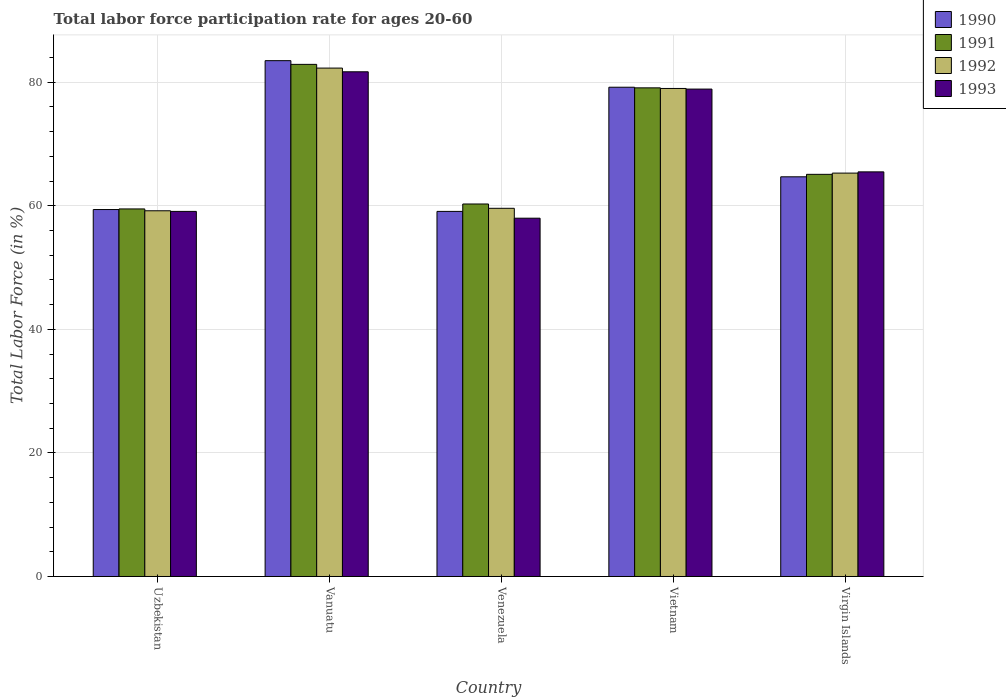Are the number of bars on each tick of the X-axis equal?
Make the answer very short. Yes. How many bars are there on the 1st tick from the left?
Ensure brevity in your answer.  4. What is the label of the 5th group of bars from the left?
Your answer should be compact. Virgin Islands. What is the labor force participation rate in 1990 in Virgin Islands?
Give a very brief answer. 64.7. Across all countries, what is the maximum labor force participation rate in 1993?
Your answer should be compact. 81.7. Across all countries, what is the minimum labor force participation rate in 1990?
Make the answer very short. 59.1. In which country was the labor force participation rate in 1991 maximum?
Offer a terse response. Vanuatu. In which country was the labor force participation rate in 1993 minimum?
Offer a very short reply. Venezuela. What is the total labor force participation rate in 1990 in the graph?
Keep it short and to the point. 345.9. What is the difference between the labor force participation rate in 1990 in Venezuela and that in Virgin Islands?
Your answer should be compact. -5.6. What is the difference between the labor force participation rate in 1992 in Vanuatu and the labor force participation rate in 1993 in Virgin Islands?
Ensure brevity in your answer.  16.8. What is the average labor force participation rate in 1993 per country?
Offer a terse response. 68.64. What is the difference between the labor force participation rate of/in 1990 and labor force participation rate of/in 1991 in Virgin Islands?
Your response must be concise. -0.4. What is the ratio of the labor force participation rate in 1991 in Venezuela to that in Vietnam?
Ensure brevity in your answer.  0.76. Is the difference between the labor force participation rate in 1990 in Vanuatu and Virgin Islands greater than the difference between the labor force participation rate in 1991 in Vanuatu and Virgin Islands?
Offer a terse response. Yes. What is the difference between the highest and the lowest labor force participation rate in 1992?
Give a very brief answer. 23.1. Is the sum of the labor force participation rate in 1992 in Venezuela and Vietnam greater than the maximum labor force participation rate in 1993 across all countries?
Offer a terse response. Yes. What does the 4th bar from the left in Virgin Islands represents?
Provide a short and direct response. 1993. Is it the case that in every country, the sum of the labor force participation rate in 1991 and labor force participation rate in 1993 is greater than the labor force participation rate in 1992?
Your answer should be compact. Yes. How many bars are there?
Your answer should be very brief. 20. Are all the bars in the graph horizontal?
Offer a terse response. No. How many countries are there in the graph?
Keep it short and to the point. 5. Does the graph contain grids?
Keep it short and to the point. Yes. Where does the legend appear in the graph?
Offer a very short reply. Top right. What is the title of the graph?
Your answer should be compact. Total labor force participation rate for ages 20-60. Does "1989" appear as one of the legend labels in the graph?
Provide a succinct answer. No. What is the Total Labor Force (in %) of 1990 in Uzbekistan?
Offer a terse response. 59.4. What is the Total Labor Force (in %) in 1991 in Uzbekistan?
Your response must be concise. 59.5. What is the Total Labor Force (in %) of 1992 in Uzbekistan?
Offer a terse response. 59.2. What is the Total Labor Force (in %) of 1993 in Uzbekistan?
Provide a succinct answer. 59.1. What is the Total Labor Force (in %) in 1990 in Vanuatu?
Your response must be concise. 83.5. What is the Total Labor Force (in %) of 1991 in Vanuatu?
Your response must be concise. 82.9. What is the Total Labor Force (in %) in 1992 in Vanuatu?
Give a very brief answer. 82.3. What is the Total Labor Force (in %) of 1993 in Vanuatu?
Keep it short and to the point. 81.7. What is the Total Labor Force (in %) of 1990 in Venezuela?
Your answer should be compact. 59.1. What is the Total Labor Force (in %) of 1991 in Venezuela?
Provide a short and direct response. 60.3. What is the Total Labor Force (in %) in 1992 in Venezuela?
Offer a terse response. 59.6. What is the Total Labor Force (in %) in 1993 in Venezuela?
Make the answer very short. 58. What is the Total Labor Force (in %) in 1990 in Vietnam?
Offer a very short reply. 79.2. What is the Total Labor Force (in %) in 1991 in Vietnam?
Give a very brief answer. 79.1. What is the Total Labor Force (in %) of 1992 in Vietnam?
Ensure brevity in your answer.  79. What is the Total Labor Force (in %) in 1993 in Vietnam?
Your answer should be compact. 78.9. What is the Total Labor Force (in %) of 1990 in Virgin Islands?
Offer a terse response. 64.7. What is the Total Labor Force (in %) of 1991 in Virgin Islands?
Your response must be concise. 65.1. What is the Total Labor Force (in %) in 1992 in Virgin Islands?
Offer a very short reply. 65.3. What is the Total Labor Force (in %) of 1993 in Virgin Islands?
Provide a succinct answer. 65.5. Across all countries, what is the maximum Total Labor Force (in %) in 1990?
Make the answer very short. 83.5. Across all countries, what is the maximum Total Labor Force (in %) of 1991?
Your answer should be very brief. 82.9. Across all countries, what is the maximum Total Labor Force (in %) of 1992?
Ensure brevity in your answer.  82.3. Across all countries, what is the maximum Total Labor Force (in %) in 1993?
Offer a terse response. 81.7. Across all countries, what is the minimum Total Labor Force (in %) in 1990?
Provide a succinct answer. 59.1. Across all countries, what is the minimum Total Labor Force (in %) of 1991?
Ensure brevity in your answer.  59.5. Across all countries, what is the minimum Total Labor Force (in %) of 1992?
Keep it short and to the point. 59.2. What is the total Total Labor Force (in %) in 1990 in the graph?
Offer a terse response. 345.9. What is the total Total Labor Force (in %) in 1991 in the graph?
Keep it short and to the point. 346.9. What is the total Total Labor Force (in %) of 1992 in the graph?
Give a very brief answer. 345.4. What is the total Total Labor Force (in %) in 1993 in the graph?
Your answer should be compact. 343.2. What is the difference between the Total Labor Force (in %) in 1990 in Uzbekistan and that in Vanuatu?
Offer a very short reply. -24.1. What is the difference between the Total Labor Force (in %) of 1991 in Uzbekistan and that in Vanuatu?
Provide a succinct answer. -23.4. What is the difference between the Total Labor Force (in %) of 1992 in Uzbekistan and that in Vanuatu?
Offer a terse response. -23.1. What is the difference between the Total Labor Force (in %) in 1993 in Uzbekistan and that in Vanuatu?
Give a very brief answer. -22.6. What is the difference between the Total Labor Force (in %) in 1990 in Uzbekistan and that in Venezuela?
Keep it short and to the point. 0.3. What is the difference between the Total Labor Force (in %) of 1991 in Uzbekistan and that in Venezuela?
Make the answer very short. -0.8. What is the difference between the Total Labor Force (in %) in 1992 in Uzbekistan and that in Venezuela?
Your answer should be compact. -0.4. What is the difference between the Total Labor Force (in %) of 1993 in Uzbekistan and that in Venezuela?
Provide a short and direct response. 1.1. What is the difference between the Total Labor Force (in %) in 1990 in Uzbekistan and that in Vietnam?
Provide a succinct answer. -19.8. What is the difference between the Total Labor Force (in %) in 1991 in Uzbekistan and that in Vietnam?
Give a very brief answer. -19.6. What is the difference between the Total Labor Force (in %) in 1992 in Uzbekistan and that in Vietnam?
Ensure brevity in your answer.  -19.8. What is the difference between the Total Labor Force (in %) of 1993 in Uzbekistan and that in Vietnam?
Your answer should be compact. -19.8. What is the difference between the Total Labor Force (in %) of 1992 in Uzbekistan and that in Virgin Islands?
Your response must be concise. -6.1. What is the difference between the Total Labor Force (in %) in 1990 in Vanuatu and that in Venezuela?
Ensure brevity in your answer.  24.4. What is the difference between the Total Labor Force (in %) of 1991 in Vanuatu and that in Venezuela?
Give a very brief answer. 22.6. What is the difference between the Total Labor Force (in %) of 1992 in Vanuatu and that in Venezuela?
Offer a terse response. 22.7. What is the difference between the Total Labor Force (in %) of 1993 in Vanuatu and that in Venezuela?
Your response must be concise. 23.7. What is the difference between the Total Labor Force (in %) of 1990 in Vanuatu and that in Vietnam?
Keep it short and to the point. 4.3. What is the difference between the Total Labor Force (in %) of 1991 in Vanuatu and that in Vietnam?
Ensure brevity in your answer.  3.8. What is the difference between the Total Labor Force (in %) of 1993 in Vanuatu and that in Vietnam?
Offer a very short reply. 2.8. What is the difference between the Total Labor Force (in %) in 1990 in Venezuela and that in Vietnam?
Offer a very short reply. -20.1. What is the difference between the Total Labor Force (in %) of 1991 in Venezuela and that in Vietnam?
Your response must be concise. -18.8. What is the difference between the Total Labor Force (in %) of 1992 in Venezuela and that in Vietnam?
Your response must be concise. -19.4. What is the difference between the Total Labor Force (in %) in 1993 in Venezuela and that in Vietnam?
Your answer should be compact. -20.9. What is the difference between the Total Labor Force (in %) of 1992 in Venezuela and that in Virgin Islands?
Your answer should be very brief. -5.7. What is the difference between the Total Labor Force (in %) in 1990 in Vietnam and that in Virgin Islands?
Offer a very short reply. 14.5. What is the difference between the Total Labor Force (in %) of 1990 in Uzbekistan and the Total Labor Force (in %) of 1991 in Vanuatu?
Ensure brevity in your answer.  -23.5. What is the difference between the Total Labor Force (in %) of 1990 in Uzbekistan and the Total Labor Force (in %) of 1992 in Vanuatu?
Give a very brief answer. -22.9. What is the difference between the Total Labor Force (in %) in 1990 in Uzbekistan and the Total Labor Force (in %) in 1993 in Vanuatu?
Give a very brief answer. -22.3. What is the difference between the Total Labor Force (in %) in 1991 in Uzbekistan and the Total Labor Force (in %) in 1992 in Vanuatu?
Offer a terse response. -22.8. What is the difference between the Total Labor Force (in %) in 1991 in Uzbekistan and the Total Labor Force (in %) in 1993 in Vanuatu?
Offer a very short reply. -22.2. What is the difference between the Total Labor Force (in %) in 1992 in Uzbekistan and the Total Labor Force (in %) in 1993 in Vanuatu?
Offer a terse response. -22.5. What is the difference between the Total Labor Force (in %) of 1990 in Uzbekistan and the Total Labor Force (in %) of 1992 in Venezuela?
Give a very brief answer. -0.2. What is the difference between the Total Labor Force (in %) in 1990 in Uzbekistan and the Total Labor Force (in %) in 1993 in Venezuela?
Your answer should be very brief. 1.4. What is the difference between the Total Labor Force (in %) of 1991 in Uzbekistan and the Total Labor Force (in %) of 1993 in Venezuela?
Offer a very short reply. 1.5. What is the difference between the Total Labor Force (in %) of 1992 in Uzbekistan and the Total Labor Force (in %) of 1993 in Venezuela?
Offer a very short reply. 1.2. What is the difference between the Total Labor Force (in %) of 1990 in Uzbekistan and the Total Labor Force (in %) of 1991 in Vietnam?
Offer a very short reply. -19.7. What is the difference between the Total Labor Force (in %) of 1990 in Uzbekistan and the Total Labor Force (in %) of 1992 in Vietnam?
Ensure brevity in your answer.  -19.6. What is the difference between the Total Labor Force (in %) of 1990 in Uzbekistan and the Total Labor Force (in %) of 1993 in Vietnam?
Your response must be concise. -19.5. What is the difference between the Total Labor Force (in %) of 1991 in Uzbekistan and the Total Labor Force (in %) of 1992 in Vietnam?
Offer a very short reply. -19.5. What is the difference between the Total Labor Force (in %) of 1991 in Uzbekistan and the Total Labor Force (in %) of 1993 in Vietnam?
Your answer should be very brief. -19.4. What is the difference between the Total Labor Force (in %) in 1992 in Uzbekistan and the Total Labor Force (in %) in 1993 in Vietnam?
Ensure brevity in your answer.  -19.7. What is the difference between the Total Labor Force (in %) of 1990 in Uzbekistan and the Total Labor Force (in %) of 1993 in Virgin Islands?
Your answer should be very brief. -6.1. What is the difference between the Total Labor Force (in %) of 1991 in Uzbekistan and the Total Labor Force (in %) of 1992 in Virgin Islands?
Offer a very short reply. -5.8. What is the difference between the Total Labor Force (in %) in 1992 in Uzbekistan and the Total Labor Force (in %) in 1993 in Virgin Islands?
Provide a short and direct response. -6.3. What is the difference between the Total Labor Force (in %) of 1990 in Vanuatu and the Total Labor Force (in %) of 1991 in Venezuela?
Ensure brevity in your answer.  23.2. What is the difference between the Total Labor Force (in %) in 1990 in Vanuatu and the Total Labor Force (in %) in 1992 in Venezuela?
Make the answer very short. 23.9. What is the difference between the Total Labor Force (in %) in 1990 in Vanuatu and the Total Labor Force (in %) in 1993 in Venezuela?
Offer a terse response. 25.5. What is the difference between the Total Labor Force (in %) in 1991 in Vanuatu and the Total Labor Force (in %) in 1992 in Venezuela?
Your response must be concise. 23.3. What is the difference between the Total Labor Force (in %) in 1991 in Vanuatu and the Total Labor Force (in %) in 1993 in Venezuela?
Offer a terse response. 24.9. What is the difference between the Total Labor Force (in %) in 1992 in Vanuatu and the Total Labor Force (in %) in 1993 in Venezuela?
Offer a very short reply. 24.3. What is the difference between the Total Labor Force (in %) of 1990 in Vanuatu and the Total Labor Force (in %) of 1991 in Vietnam?
Your response must be concise. 4.4. What is the difference between the Total Labor Force (in %) in 1990 in Vanuatu and the Total Labor Force (in %) in 1992 in Vietnam?
Keep it short and to the point. 4.5. What is the difference between the Total Labor Force (in %) in 1992 in Vanuatu and the Total Labor Force (in %) in 1993 in Vietnam?
Give a very brief answer. 3.4. What is the difference between the Total Labor Force (in %) of 1991 in Vanuatu and the Total Labor Force (in %) of 1993 in Virgin Islands?
Offer a terse response. 17.4. What is the difference between the Total Labor Force (in %) of 1990 in Venezuela and the Total Labor Force (in %) of 1992 in Vietnam?
Ensure brevity in your answer.  -19.9. What is the difference between the Total Labor Force (in %) of 1990 in Venezuela and the Total Labor Force (in %) of 1993 in Vietnam?
Your response must be concise. -19.8. What is the difference between the Total Labor Force (in %) in 1991 in Venezuela and the Total Labor Force (in %) in 1992 in Vietnam?
Make the answer very short. -18.7. What is the difference between the Total Labor Force (in %) of 1991 in Venezuela and the Total Labor Force (in %) of 1993 in Vietnam?
Give a very brief answer. -18.6. What is the difference between the Total Labor Force (in %) in 1992 in Venezuela and the Total Labor Force (in %) in 1993 in Vietnam?
Give a very brief answer. -19.3. What is the difference between the Total Labor Force (in %) of 1990 in Venezuela and the Total Labor Force (in %) of 1991 in Virgin Islands?
Offer a very short reply. -6. What is the difference between the Total Labor Force (in %) of 1990 in Venezuela and the Total Labor Force (in %) of 1993 in Virgin Islands?
Your answer should be compact. -6.4. What is the difference between the Total Labor Force (in %) in 1992 in Venezuela and the Total Labor Force (in %) in 1993 in Virgin Islands?
Ensure brevity in your answer.  -5.9. What is the difference between the Total Labor Force (in %) in 1990 in Vietnam and the Total Labor Force (in %) in 1991 in Virgin Islands?
Give a very brief answer. 14.1. What is the difference between the Total Labor Force (in %) in 1990 in Vietnam and the Total Labor Force (in %) in 1992 in Virgin Islands?
Provide a succinct answer. 13.9. What is the difference between the Total Labor Force (in %) in 1991 in Vietnam and the Total Labor Force (in %) in 1992 in Virgin Islands?
Offer a very short reply. 13.8. What is the difference between the Total Labor Force (in %) in 1991 in Vietnam and the Total Labor Force (in %) in 1993 in Virgin Islands?
Offer a terse response. 13.6. What is the difference between the Total Labor Force (in %) in 1992 in Vietnam and the Total Labor Force (in %) in 1993 in Virgin Islands?
Keep it short and to the point. 13.5. What is the average Total Labor Force (in %) in 1990 per country?
Your answer should be very brief. 69.18. What is the average Total Labor Force (in %) of 1991 per country?
Provide a succinct answer. 69.38. What is the average Total Labor Force (in %) of 1992 per country?
Your answer should be compact. 69.08. What is the average Total Labor Force (in %) in 1993 per country?
Provide a succinct answer. 68.64. What is the difference between the Total Labor Force (in %) of 1990 and Total Labor Force (in %) of 1991 in Uzbekistan?
Offer a very short reply. -0.1. What is the difference between the Total Labor Force (in %) of 1990 and Total Labor Force (in %) of 1992 in Uzbekistan?
Give a very brief answer. 0.2. What is the difference between the Total Labor Force (in %) in 1990 and Total Labor Force (in %) in 1993 in Uzbekistan?
Provide a short and direct response. 0.3. What is the difference between the Total Labor Force (in %) in 1991 and Total Labor Force (in %) in 1992 in Uzbekistan?
Ensure brevity in your answer.  0.3. What is the difference between the Total Labor Force (in %) of 1991 and Total Labor Force (in %) of 1993 in Uzbekistan?
Make the answer very short. 0.4. What is the difference between the Total Labor Force (in %) of 1990 and Total Labor Force (in %) of 1991 in Vanuatu?
Keep it short and to the point. 0.6. What is the difference between the Total Labor Force (in %) in 1990 and Total Labor Force (in %) in 1992 in Vanuatu?
Give a very brief answer. 1.2. What is the difference between the Total Labor Force (in %) of 1991 and Total Labor Force (in %) of 1992 in Vanuatu?
Give a very brief answer. 0.6. What is the difference between the Total Labor Force (in %) of 1991 and Total Labor Force (in %) of 1993 in Vanuatu?
Provide a succinct answer. 1.2. What is the difference between the Total Labor Force (in %) in 1990 and Total Labor Force (in %) in 1992 in Venezuela?
Ensure brevity in your answer.  -0.5. What is the difference between the Total Labor Force (in %) in 1991 and Total Labor Force (in %) in 1992 in Venezuela?
Your answer should be compact. 0.7. What is the difference between the Total Labor Force (in %) of 1991 and Total Labor Force (in %) of 1993 in Venezuela?
Give a very brief answer. 2.3. What is the difference between the Total Labor Force (in %) in 1992 and Total Labor Force (in %) in 1993 in Venezuela?
Make the answer very short. 1.6. What is the difference between the Total Labor Force (in %) in 1990 and Total Labor Force (in %) in 1992 in Vietnam?
Make the answer very short. 0.2. What is the difference between the Total Labor Force (in %) in 1991 and Total Labor Force (in %) in 1993 in Vietnam?
Offer a very short reply. 0.2. What is the difference between the Total Labor Force (in %) of 1990 and Total Labor Force (in %) of 1992 in Virgin Islands?
Make the answer very short. -0.6. What is the difference between the Total Labor Force (in %) in 1990 and Total Labor Force (in %) in 1993 in Virgin Islands?
Provide a short and direct response. -0.8. What is the difference between the Total Labor Force (in %) of 1992 and Total Labor Force (in %) of 1993 in Virgin Islands?
Ensure brevity in your answer.  -0.2. What is the ratio of the Total Labor Force (in %) in 1990 in Uzbekistan to that in Vanuatu?
Make the answer very short. 0.71. What is the ratio of the Total Labor Force (in %) in 1991 in Uzbekistan to that in Vanuatu?
Keep it short and to the point. 0.72. What is the ratio of the Total Labor Force (in %) of 1992 in Uzbekistan to that in Vanuatu?
Provide a succinct answer. 0.72. What is the ratio of the Total Labor Force (in %) of 1993 in Uzbekistan to that in Vanuatu?
Your answer should be compact. 0.72. What is the ratio of the Total Labor Force (in %) in 1990 in Uzbekistan to that in Venezuela?
Your response must be concise. 1.01. What is the ratio of the Total Labor Force (in %) of 1991 in Uzbekistan to that in Venezuela?
Make the answer very short. 0.99. What is the ratio of the Total Labor Force (in %) in 1993 in Uzbekistan to that in Venezuela?
Your response must be concise. 1.02. What is the ratio of the Total Labor Force (in %) of 1991 in Uzbekistan to that in Vietnam?
Your response must be concise. 0.75. What is the ratio of the Total Labor Force (in %) in 1992 in Uzbekistan to that in Vietnam?
Your response must be concise. 0.75. What is the ratio of the Total Labor Force (in %) of 1993 in Uzbekistan to that in Vietnam?
Your answer should be very brief. 0.75. What is the ratio of the Total Labor Force (in %) in 1990 in Uzbekistan to that in Virgin Islands?
Offer a very short reply. 0.92. What is the ratio of the Total Labor Force (in %) in 1991 in Uzbekistan to that in Virgin Islands?
Keep it short and to the point. 0.91. What is the ratio of the Total Labor Force (in %) in 1992 in Uzbekistan to that in Virgin Islands?
Your answer should be very brief. 0.91. What is the ratio of the Total Labor Force (in %) in 1993 in Uzbekistan to that in Virgin Islands?
Your answer should be compact. 0.9. What is the ratio of the Total Labor Force (in %) of 1990 in Vanuatu to that in Venezuela?
Make the answer very short. 1.41. What is the ratio of the Total Labor Force (in %) in 1991 in Vanuatu to that in Venezuela?
Ensure brevity in your answer.  1.37. What is the ratio of the Total Labor Force (in %) in 1992 in Vanuatu to that in Venezuela?
Provide a succinct answer. 1.38. What is the ratio of the Total Labor Force (in %) of 1993 in Vanuatu to that in Venezuela?
Your answer should be compact. 1.41. What is the ratio of the Total Labor Force (in %) of 1990 in Vanuatu to that in Vietnam?
Ensure brevity in your answer.  1.05. What is the ratio of the Total Labor Force (in %) in 1991 in Vanuatu to that in Vietnam?
Offer a very short reply. 1.05. What is the ratio of the Total Labor Force (in %) of 1992 in Vanuatu to that in Vietnam?
Offer a terse response. 1.04. What is the ratio of the Total Labor Force (in %) of 1993 in Vanuatu to that in Vietnam?
Offer a terse response. 1.04. What is the ratio of the Total Labor Force (in %) of 1990 in Vanuatu to that in Virgin Islands?
Offer a very short reply. 1.29. What is the ratio of the Total Labor Force (in %) of 1991 in Vanuatu to that in Virgin Islands?
Make the answer very short. 1.27. What is the ratio of the Total Labor Force (in %) in 1992 in Vanuatu to that in Virgin Islands?
Offer a terse response. 1.26. What is the ratio of the Total Labor Force (in %) of 1993 in Vanuatu to that in Virgin Islands?
Ensure brevity in your answer.  1.25. What is the ratio of the Total Labor Force (in %) of 1990 in Venezuela to that in Vietnam?
Provide a short and direct response. 0.75. What is the ratio of the Total Labor Force (in %) of 1991 in Venezuela to that in Vietnam?
Offer a terse response. 0.76. What is the ratio of the Total Labor Force (in %) in 1992 in Venezuela to that in Vietnam?
Your response must be concise. 0.75. What is the ratio of the Total Labor Force (in %) in 1993 in Venezuela to that in Vietnam?
Your answer should be very brief. 0.74. What is the ratio of the Total Labor Force (in %) of 1990 in Venezuela to that in Virgin Islands?
Keep it short and to the point. 0.91. What is the ratio of the Total Labor Force (in %) in 1991 in Venezuela to that in Virgin Islands?
Your answer should be compact. 0.93. What is the ratio of the Total Labor Force (in %) in 1992 in Venezuela to that in Virgin Islands?
Offer a very short reply. 0.91. What is the ratio of the Total Labor Force (in %) of 1993 in Venezuela to that in Virgin Islands?
Offer a terse response. 0.89. What is the ratio of the Total Labor Force (in %) in 1990 in Vietnam to that in Virgin Islands?
Keep it short and to the point. 1.22. What is the ratio of the Total Labor Force (in %) of 1991 in Vietnam to that in Virgin Islands?
Make the answer very short. 1.22. What is the ratio of the Total Labor Force (in %) in 1992 in Vietnam to that in Virgin Islands?
Your answer should be very brief. 1.21. What is the ratio of the Total Labor Force (in %) in 1993 in Vietnam to that in Virgin Islands?
Keep it short and to the point. 1.2. What is the difference between the highest and the second highest Total Labor Force (in %) of 1991?
Your answer should be compact. 3.8. What is the difference between the highest and the second highest Total Labor Force (in %) in 1992?
Offer a terse response. 3.3. What is the difference between the highest and the lowest Total Labor Force (in %) in 1990?
Your response must be concise. 24.4. What is the difference between the highest and the lowest Total Labor Force (in %) in 1991?
Your response must be concise. 23.4. What is the difference between the highest and the lowest Total Labor Force (in %) of 1992?
Give a very brief answer. 23.1. What is the difference between the highest and the lowest Total Labor Force (in %) of 1993?
Provide a succinct answer. 23.7. 